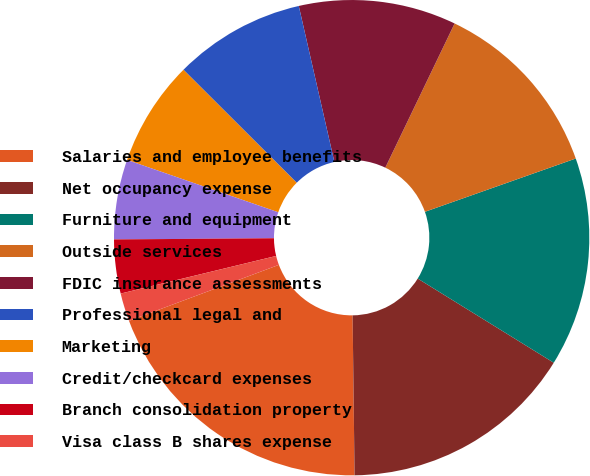Convert chart. <chart><loc_0><loc_0><loc_500><loc_500><pie_chart><fcel>Salaries and employee benefits<fcel>Net occupancy expense<fcel>Furniture and equipment<fcel>Outside services<fcel>FDIC insurance assessments<fcel>Professional legal and<fcel>Marketing<fcel>Credit/checkcard expenses<fcel>Branch consolidation property<fcel>Visa class B shares expense<nl><fcel>19.5%<fcel>15.98%<fcel>14.22%<fcel>12.46%<fcel>10.7%<fcel>8.94%<fcel>7.18%<fcel>5.42%<fcel>3.66%<fcel>1.91%<nl></chart> 